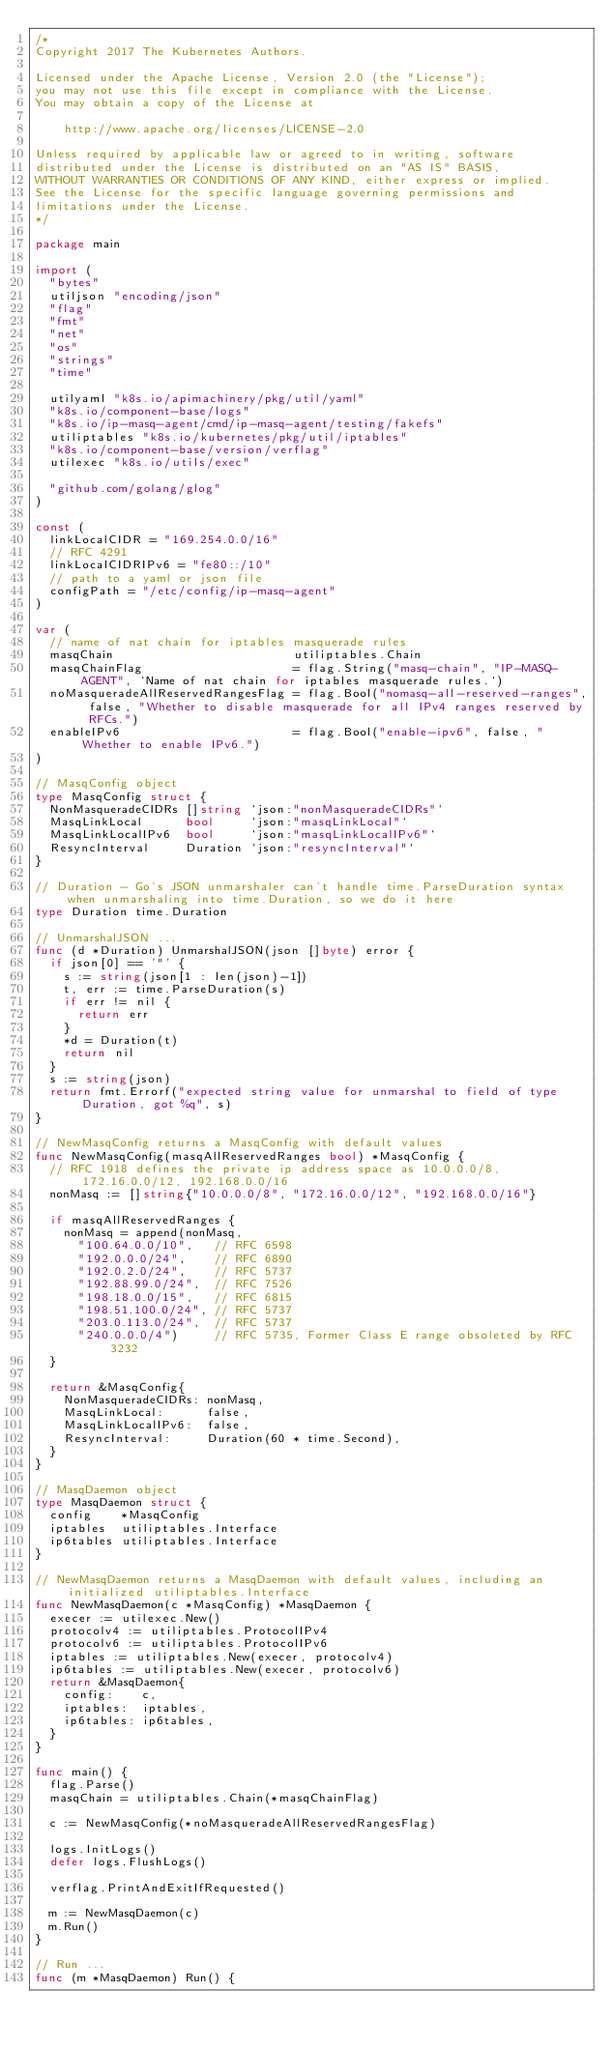Convert code to text. <code><loc_0><loc_0><loc_500><loc_500><_Go_>/*
Copyright 2017 The Kubernetes Authors.

Licensed under the Apache License, Version 2.0 (the "License");
you may not use this file except in compliance with the License.
You may obtain a copy of the License at

    http://www.apache.org/licenses/LICENSE-2.0

Unless required by applicable law or agreed to in writing, software
distributed under the License is distributed on an "AS IS" BASIS,
WITHOUT WARRANTIES OR CONDITIONS OF ANY KIND, either express or implied.
See the License for the specific language governing permissions and
limitations under the License.
*/

package main

import (
	"bytes"
	utiljson "encoding/json"
	"flag"
	"fmt"
	"net"
	"os"
	"strings"
	"time"

	utilyaml "k8s.io/apimachinery/pkg/util/yaml"
	"k8s.io/component-base/logs"
	"k8s.io/ip-masq-agent/cmd/ip-masq-agent/testing/fakefs"
	utiliptables "k8s.io/kubernetes/pkg/util/iptables"
	"k8s.io/component-base/version/verflag"
	utilexec "k8s.io/utils/exec"

	"github.com/golang/glog"
)

const (
	linkLocalCIDR = "169.254.0.0/16"
	// RFC 4291
	linkLocalCIDRIPv6 = "fe80::/10"
	// path to a yaml or json file
	configPath = "/etc/config/ip-masq-agent"
)

var (
	// name of nat chain for iptables masquerade rules
	masqChain                         utiliptables.Chain
	masqChainFlag                     = flag.String("masq-chain", "IP-MASQ-AGENT", `Name of nat chain for iptables masquerade rules.`)
	noMasqueradeAllReservedRangesFlag = flag.Bool("nomasq-all-reserved-ranges", false, "Whether to disable masquerade for all IPv4 ranges reserved by RFCs.")
	enableIPv6                        = flag.Bool("enable-ipv6", false, "Whether to enable IPv6.")
)

// MasqConfig object
type MasqConfig struct {
	NonMasqueradeCIDRs []string `json:"nonMasqueradeCIDRs"`
	MasqLinkLocal      bool     `json:"masqLinkLocal"`
	MasqLinkLocalIPv6  bool     `json:"masqLinkLocalIPv6"`
	ResyncInterval     Duration `json:"resyncInterval"`
}

// Duration - Go's JSON unmarshaler can't handle time.ParseDuration syntax when unmarshaling into time.Duration, so we do it here
type Duration time.Duration

// UnmarshalJSON ...
func (d *Duration) UnmarshalJSON(json []byte) error {
	if json[0] == '"' {
		s := string(json[1 : len(json)-1])
		t, err := time.ParseDuration(s)
		if err != nil {
			return err
		}
		*d = Duration(t)
		return nil
	}
	s := string(json)
	return fmt.Errorf("expected string value for unmarshal to field of type Duration, got %q", s)
}

// NewMasqConfig returns a MasqConfig with default values
func NewMasqConfig(masqAllReservedRanges bool) *MasqConfig {
	// RFC 1918 defines the private ip address space as 10.0.0.0/8, 172.16.0.0/12, 192.168.0.0/16
	nonMasq := []string{"10.0.0.0/8", "172.16.0.0/12", "192.168.0.0/16"}

	if masqAllReservedRanges {
		nonMasq = append(nonMasq,
			"100.64.0.0/10",   // RFC 6598
			"192.0.0.0/24",    // RFC 6890
			"192.0.2.0/24",    // RFC 5737
			"192.88.99.0/24",  // RFC 7526
			"198.18.0.0/15",   // RFC 6815
			"198.51.100.0/24", // RFC 5737
			"203.0.113.0/24",  // RFC 5737
			"240.0.0.0/4")     // RFC 5735, Former Class E range obsoleted by RFC 3232
	}

	return &MasqConfig{
		NonMasqueradeCIDRs: nonMasq,
		MasqLinkLocal:      false,
		MasqLinkLocalIPv6:  false,
		ResyncInterval:     Duration(60 * time.Second),
	}
}

// MasqDaemon object
type MasqDaemon struct {
	config    *MasqConfig
	iptables  utiliptables.Interface
	ip6tables utiliptables.Interface
}

// NewMasqDaemon returns a MasqDaemon with default values, including an initialized utiliptables.Interface
func NewMasqDaemon(c *MasqConfig) *MasqDaemon {
	execer := utilexec.New()
	protocolv4 := utiliptables.ProtocolIPv4
	protocolv6 := utiliptables.ProtocolIPv6
	iptables := utiliptables.New(execer, protocolv4)
	ip6tables := utiliptables.New(execer, protocolv6)
	return &MasqDaemon{
		config:    c,
		iptables:  iptables,
		ip6tables: ip6tables,
	}
}

func main() {
	flag.Parse()
	masqChain = utiliptables.Chain(*masqChainFlag)

	c := NewMasqConfig(*noMasqueradeAllReservedRangesFlag)

	logs.InitLogs()
	defer logs.FlushLogs()

	verflag.PrintAndExitIfRequested()

	m := NewMasqDaemon(c)
	m.Run()
}

// Run ...
func (m *MasqDaemon) Run() {</code> 